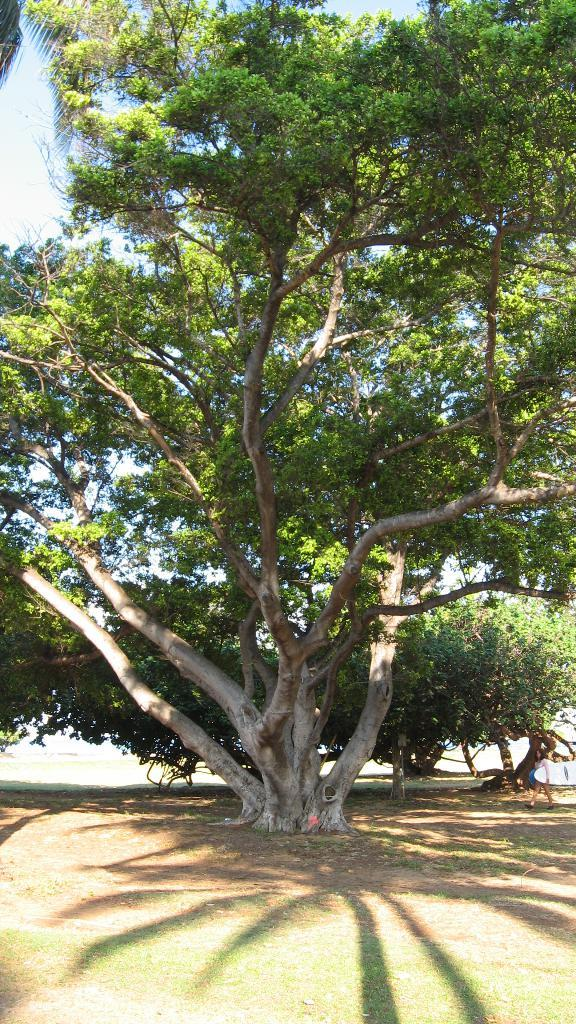What type of vegetation can be seen in the image? There are trees in the image. What is visible at the top of the image? The sky is visible at the top of the image. Where is the cork placed on the shelf in the image? There is no cork or shelf present in the image. What type of ship can be seen sailing in the image? There is no ship visible in the image; it only features trees and the sky. 